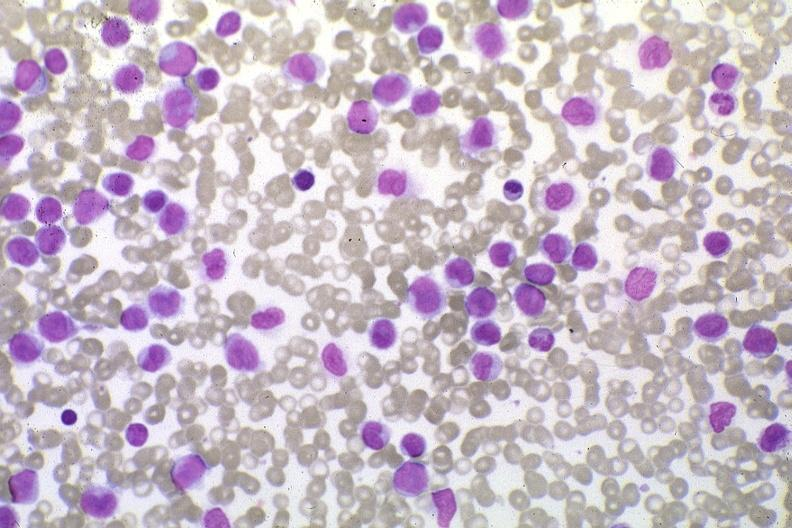s hematologic present?
Answer the question using a single word or phrase. Yes 